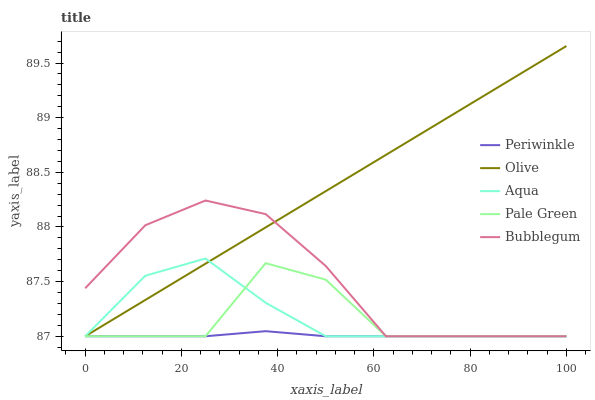Does Aqua have the minimum area under the curve?
Answer yes or no. No. Does Aqua have the maximum area under the curve?
Answer yes or no. No. Is Aqua the smoothest?
Answer yes or no. No. Is Aqua the roughest?
Answer yes or no. No. Does Aqua have the highest value?
Answer yes or no. No. 